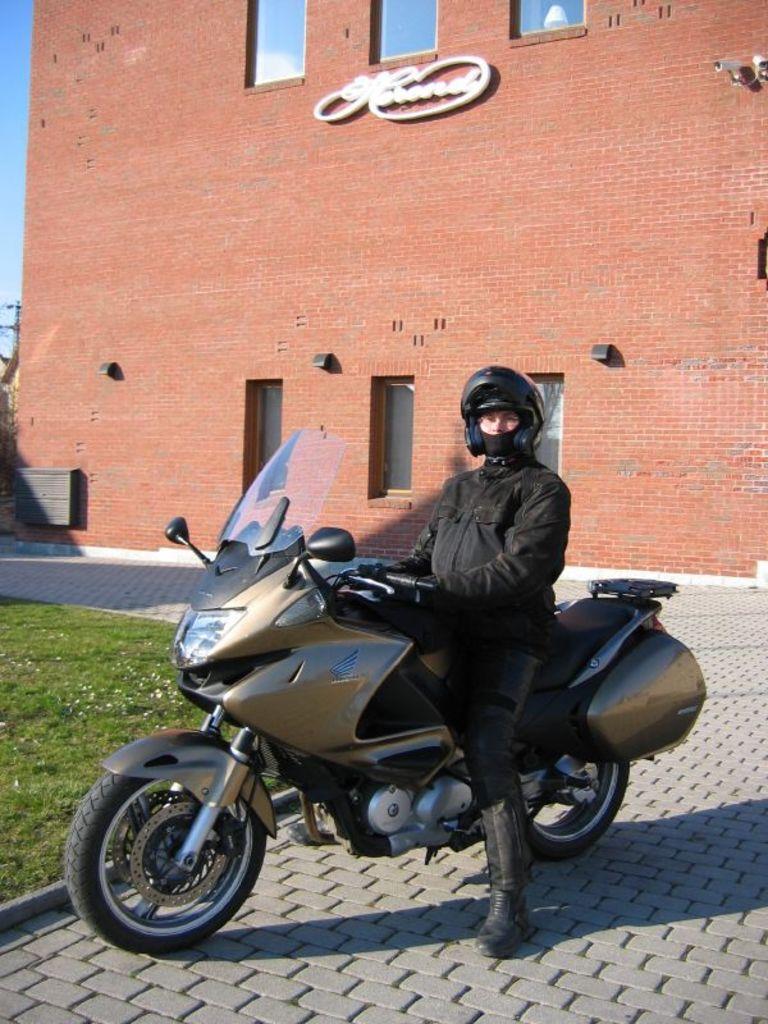Could you give a brief overview of what you see in this image? In this image there is a man sitting in a motor bike , in a street and beside him there is grass, flowers and at the back ground there is buildings, sky, cc camera, pole. 